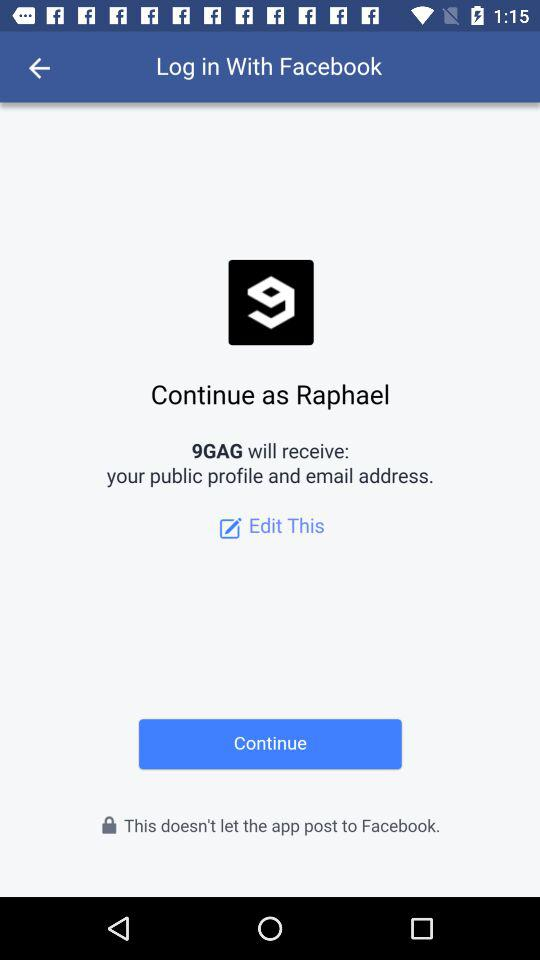Which information will "9GAG" receive? "9GAG" will receive your public profile and email address. 